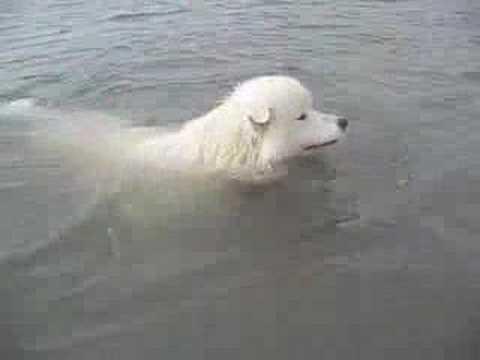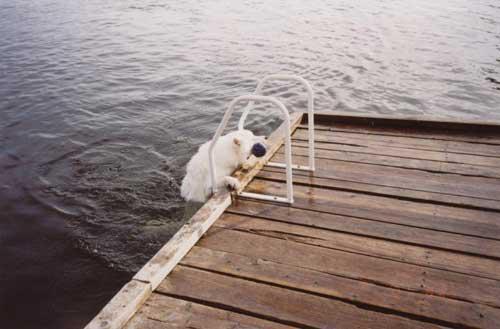The first image is the image on the left, the second image is the image on the right. Given the left and right images, does the statement "There is at least one person visible" hold true? Answer yes or no. No. The first image is the image on the left, the second image is the image on the right. Evaluate the accuracy of this statement regarding the images: "There is a human with a white dog surrounded by water in the left image.". Is it true? Answer yes or no. No. 